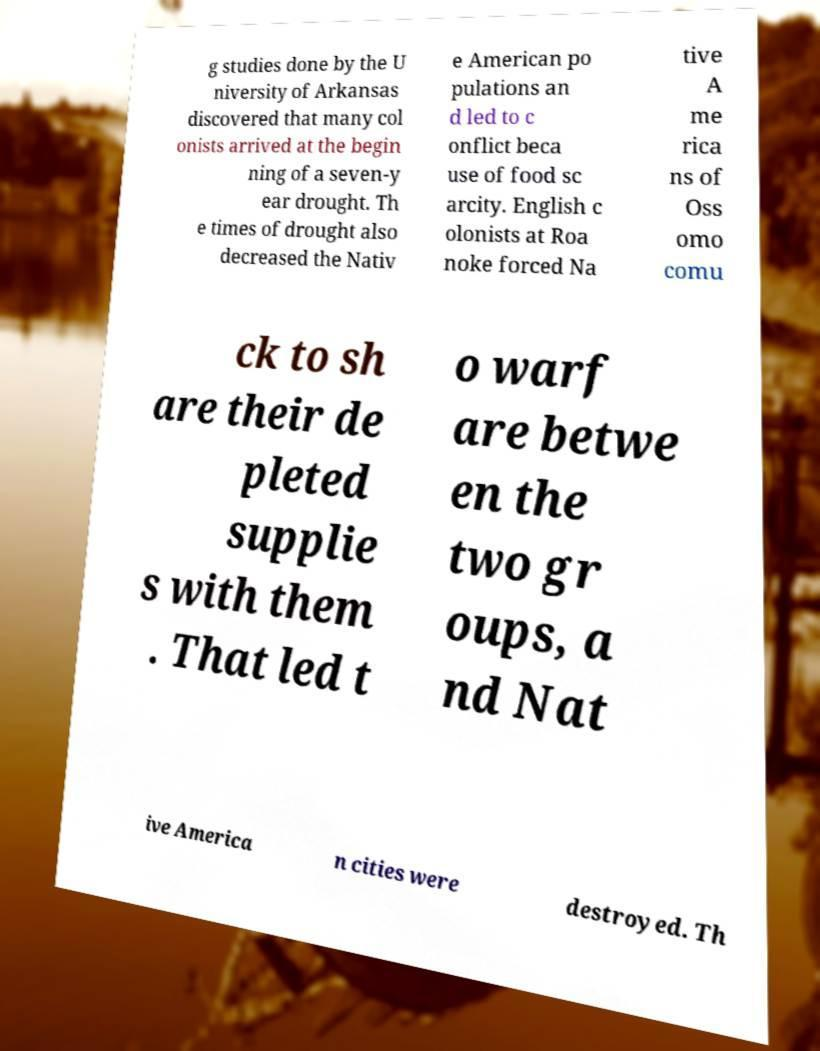What messages or text are displayed in this image? I need them in a readable, typed format. g studies done by the U niversity of Arkansas discovered that many col onists arrived at the begin ning of a seven-y ear drought. Th e times of drought also decreased the Nativ e American po pulations an d led to c onflict beca use of food sc arcity. English c olonists at Roa noke forced Na tive A me rica ns of Oss omo comu ck to sh are their de pleted supplie s with them . That led t o warf are betwe en the two gr oups, a nd Nat ive America n cities were destroyed. Th 